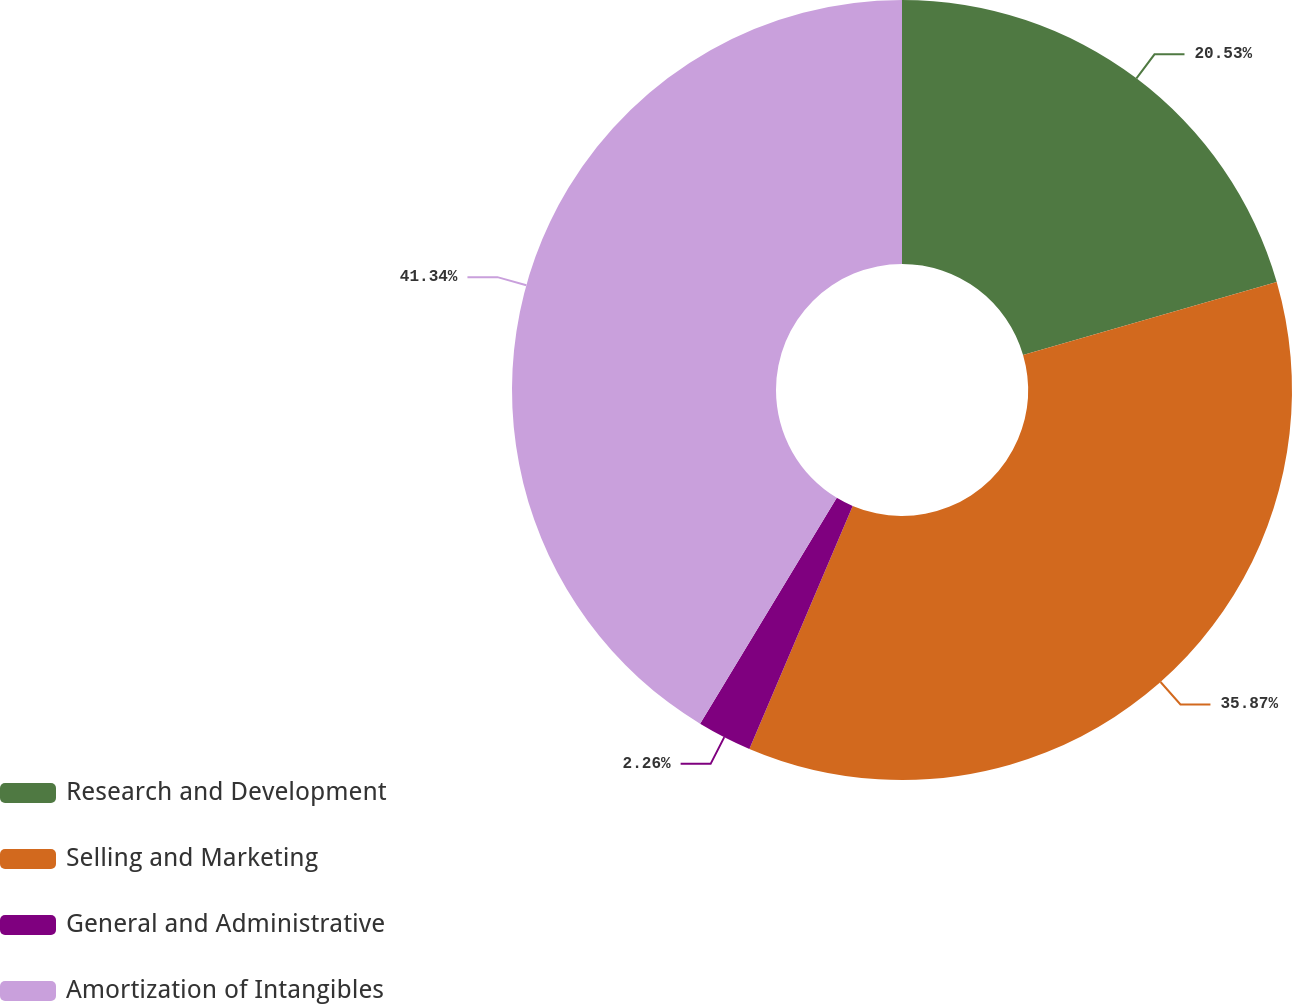Convert chart. <chart><loc_0><loc_0><loc_500><loc_500><pie_chart><fcel>Research and Development<fcel>Selling and Marketing<fcel>General and Administrative<fcel>Amortization of Intangibles<nl><fcel>20.53%<fcel>35.87%<fcel>2.26%<fcel>41.34%<nl></chart> 